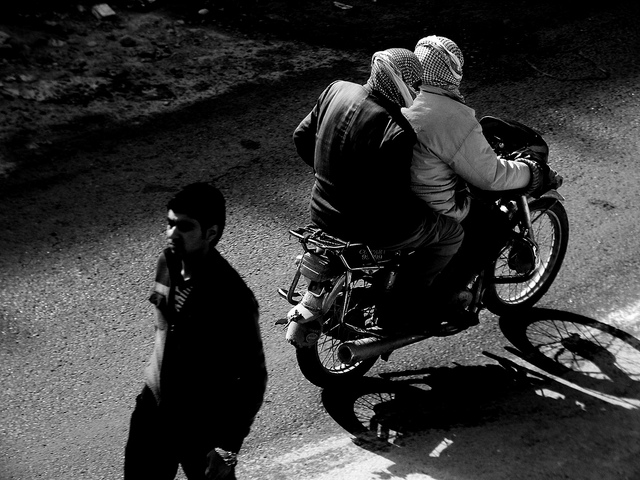How many people are on the motorcycle? There are two individuals on the motorcycle, one operating the vehicle and another rider sitting behind them, both appearing to be adults. 